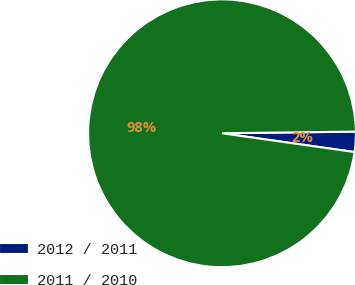Convert chart. <chart><loc_0><loc_0><loc_500><loc_500><pie_chart><fcel>2012 / 2011<fcel>2011 / 2010<nl><fcel>2.44%<fcel>97.56%<nl></chart> 